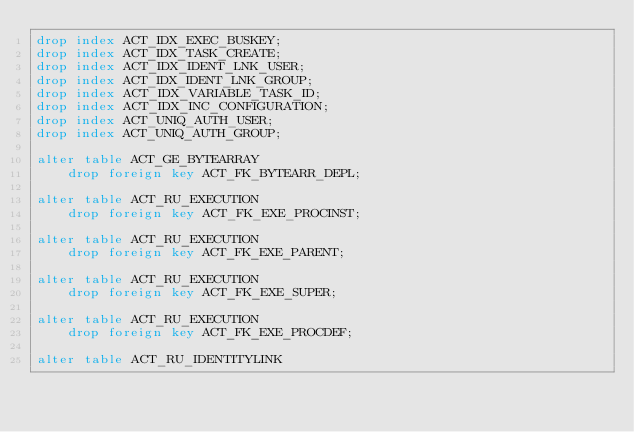<code> <loc_0><loc_0><loc_500><loc_500><_SQL_>drop index ACT_IDX_EXEC_BUSKEY;
drop index ACT_IDX_TASK_CREATE;
drop index ACT_IDX_IDENT_LNK_USER;
drop index ACT_IDX_IDENT_LNK_GROUP;
drop index ACT_IDX_VARIABLE_TASK_ID;
drop index ACT_IDX_INC_CONFIGURATION;
drop index ACT_UNIQ_AUTH_USER;
drop index ACT_UNIQ_AUTH_GROUP;

alter table ACT_GE_BYTEARRAY 
    drop foreign key ACT_FK_BYTEARR_DEPL;

alter table ACT_RU_EXECUTION
    drop foreign key ACT_FK_EXE_PROCINST;

alter table ACT_RU_EXECUTION 
    drop foreign key ACT_FK_EXE_PARENT;

alter table ACT_RU_EXECUTION 
    drop foreign key ACT_FK_EXE_SUPER;
    
alter table ACT_RU_EXECUTION 
    drop foreign key ACT_FK_EXE_PROCDEF;

alter table ACT_RU_IDENTITYLINK</code> 